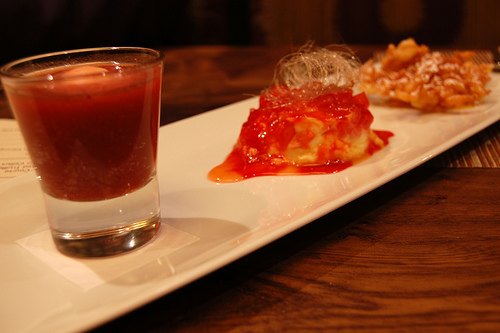<image>
Is the glass to the left of the table? No. The glass is not to the left of the table. From this viewpoint, they have a different horizontal relationship. 